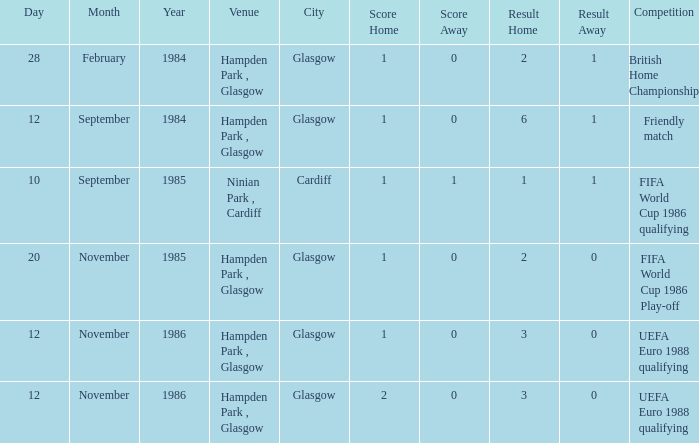What is the Date of the Competition with a Result of 3–0? 12 November 1986, 12 November 1986. 